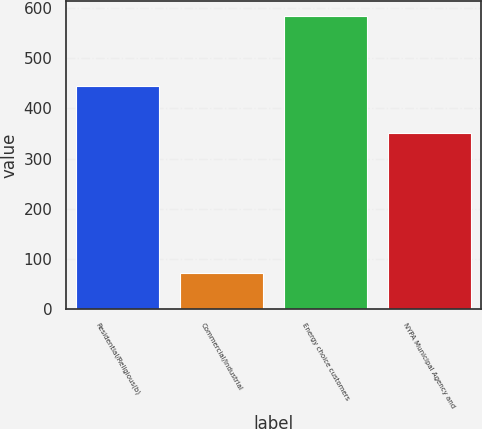Convert chart. <chart><loc_0><loc_0><loc_500><loc_500><bar_chart><fcel>Residential/Religious(b)<fcel>Commercial/Industrial<fcel>Energy choice customers<fcel>NYPA Municipal Agency and<nl><fcel>445<fcel>72<fcel>584<fcel>350<nl></chart> 